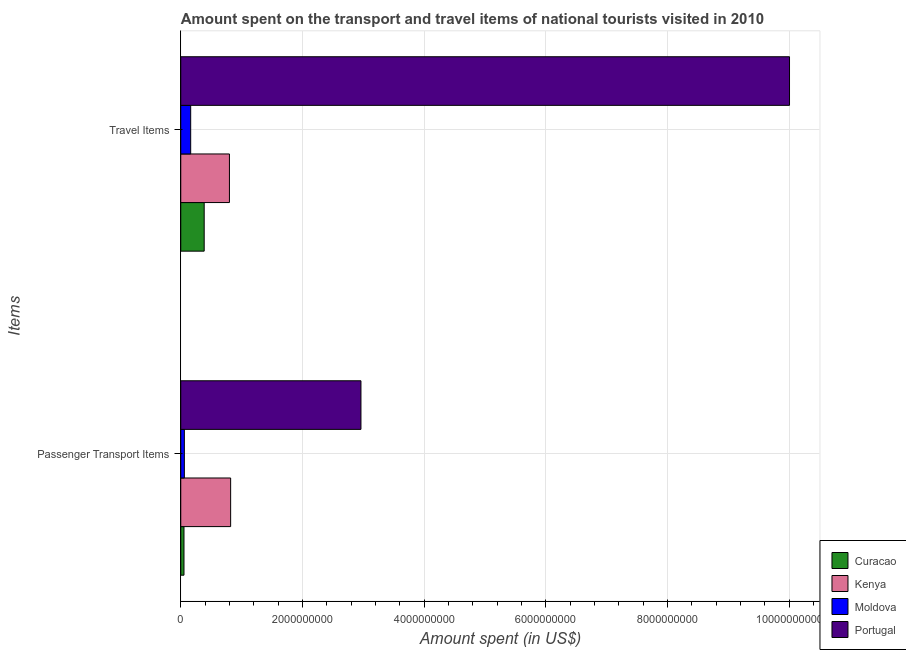How many different coloured bars are there?
Make the answer very short. 4. Are the number of bars per tick equal to the number of legend labels?
Keep it short and to the point. Yes. How many bars are there on the 2nd tick from the top?
Your answer should be compact. 4. What is the label of the 1st group of bars from the top?
Ensure brevity in your answer.  Travel Items. What is the amount spent in travel items in Kenya?
Give a very brief answer. 8.00e+08. Across all countries, what is the maximum amount spent on passenger transport items?
Offer a terse response. 2.96e+09. Across all countries, what is the minimum amount spent on passenger transport items?
Offer a terse response. 5.30e+07. In which country was the amount spent in travel items minimum?
Keep it short and to the point. Moldova. What is the total amount spent in travel items in the graph?
Make the answer very short. 1.14e+1. What is the difference between the amount spent on passenger transport items in Curacao and that in Portugal?
Your answer should be very brief. -2.91e+09. What is the difference between the amount spent on passenger transport items in Curacao and the amount spent in travel items in Portugal?
Provide a succinct answer. -9.95e+09. What is the average amount spent on passenger transport items per country?
Offer a terse response. 9.74e+08. What is the difference between the amount spent on passenger transport items and amount spent in travel items in Portugal?
Make the answer very short. -7.04e+09. In how many countries, is the amount spent in travel items greater than 8400000000 US$?
Keep it short and to the point. 1. What is the ratio of the amount spent in travel items in Portugal to that in Curacao?
Provide a succinct answer. 25.99. In how many countries, is the amount spent in travel items greater than the average amount spent in travel items taken over all countries?
Your answer should be very brief. 1. What does the 1st bar from the top in Passenger Transport Items represents?
Make the answer very short. Portugal. What does the 2nd bar from the bottom in Travel Items represents?
Provide a succinct answer. Kenya. What is the difference between two consecutive major ticks on the X-axis?
Ensure brevity in your answer.  2.00e+09. Does the graph contain any zero values?
Make the answer very short. No. What is the title of the graph?
Give a very brief answer. Amount spent on the transport and travel items of national tourists visited in 2010. Does "Comoros" appear as one of the legend labels in the graph?
Your answer should be very brief. No. What is the label or title of the X-axis?
Keep it short and to the point. Amount spent (in US$). What is the label or title of the Y-axis?
Your response must be concise. Items. What is the Amount spent (in US$) of Curacao in Passenger Transport Items?
Keep it short and to the point. 5.30e+07. What is the Amount spent (in US$) in Kenya in Passenger Transport Items?
Give a very brief answer. 8.20e+08. What is the Amount spent (in US$) in Moldova in Passenger Transport Items?
Your answer should be compact. 5.90e+07. What is the Amount spent (in US$) of Portugal in Passenger Transport Items?
Your answer should be very brief. 2.96e+09. What is the Amount spent (in US$) in Curacao in Travel Items?
Your answer should be very brief. 3.85e+08. What is the Amount spent (in US$) in Kenya in Travel Items?
Offer a very short reply. 8.00e+08. What is the Amount spent (in US$) in Moldova in Travel Items?
Your answer should be very brief. 1.63e+08. What is the Amount spent (in US$) of Portugal in Travel Items?
Ensure brevity in your answer.  1.00e+1. Across all Items, what is the maximum Amount spent (in US$) of Curacao?
Your answer should be compact. 3.85e+08. Across all Items, what is the maximum Amount spent (in US$) in Kenya?
Offer a terse response. 8.20e+08. Across all Items, what is the maximum Amount spent (in US$) in Moldova?
Offer a very short reply. 1.63e+08. Across all Items, what is the maximum Amount spent (in US$) of Portugal?
Your answer should be very brief. 1.00e+1. Across all Items, what is the minimum Amount spent (in US$) of Curacao?
Make the answer very short. 5.30e+07. Across all Items, what is the minimum Amount spent (in US$) in Kenya?
Provide a short and direct response. 8.00e+08. Across all Items, what is the minimum Amount spent (in US$) in Moldova?
Provide a succinct answer. 5.90e+07. Across all Items, what is the minimum Amount spent (in US$) of Portugal?
Provide a short and direct response. 2.96e+09. What is the total Amount spent (in US$) in Curacao in the graph?
Give a very brief answer. 4.38e+08. What is the total Amount spent (in US$) of Kenya in the graph?
Give a very brief answer. 1.62e+09. What is the total Amount spent (in US$) in Moldova in the graph?
Offer a very short reply. 2.22e+08. What is the total Amount spent (in US$) of Portugal in the graph?
Your response must be concise. 1.30e+1. What is the difference between the Amount spent (in US$) of Curacao in Passenger Transport Items and that in Travel Items?
Keep it short and to the point. -3.32e+08. What is the difference between the Amount spent (in US$) of Kenya in Passenger Transport Items and that in Travel Items?
Your answer should be very brief. 2.00e+07. What is the difference between the Amount spent (in US$) of Moldova in Passenger Transport Items and that in Travel Items?
Offer a very short reply. -1.04e+08. What is the difference between the Amount spent (in US$) of Portugal in Passenger Transport Items and that in Travel Items?
Provide a short and direct response. -7.04e+09. What is the difference between the Amount spent (in US$) in Curacao in Passenger Transport Items and the Amount spent (in US$) in Kenya in Travel Items?
Ensure brevity in your answer.  -7.47e+08. What is the difference between the Amount spent (in US$) in Curacao in Passenger Transport Items and the Amount spent (in US$) in Moldova in Travel Items?
Give a very brief answer. -1.10e+08. What is the difference between the Amount spent (in US$) in Curacao in Passenger Transport Items and the Amount spent (in US$) in Portugal in Travel Items?
Your answer should be very brief. -9.95e+09. What is the difference between the Amount spent (in US$) in Kenya in Passenger Transport Items and the Amount spent (in US$) in Moldova in Travel Items?
Provide a succinct answer. 6.57e+08. What is the difference between the Amount spent (in US$) in Kenya in Passenger Transport Items and the Amount spent (in US$) in Portugal in Travel Items?
Provide a short and direct response. -9.19e+09. What is the difference between the Amount spent (in US$) of Moldova in Passenger Transport Items and the Amount spent (in US$) of Portugal in Travel Items?
Offer a terse response. -9.95e+09. What is the average Amount spent (in US$) of Curacao per Items?
Your answer should be very brief. 2.19e+08. What is the average Amount spent (in US$) in Kenya per Items?
Offer a terse response. 8.10e+08. What is the average Amount spent (in US$) in Moldova per Items?
Keep it short and to the point. 1.11e+08. What is the average Amount spent (in US$) of Portugal per Items?
Your answer should be very brief. 6.48e+09. What is the difference between the Amount spent (in US$) in Curacao and Amount spent (in US$) in Kenya in Passenger Transport Items?
Your answer should be compact. -7.67e+08. What is the difference between the Amount spent (in US$) in Curacao and Amount spent (in US$) in Moldova in Passenger Transport Items?
Your response must be concise. -6.00e+06. What is the difference between the Amount spent (in US$) of Curacao and Amount spent (in US$) of Portugal in Passenger Transport Items?
Provide a succinct answer. -2.91e+09. What is the difference between the Amount spent (in US$) of Kenya and Amount spent (in US$) of Moldova in Passenger Transport Items?
Make the answer very short. 7.61e+08. What is the difference between the Amount spent (in US$) of Kenya and Amount spent (in US$) of Portugal in Passenger Transport Items?
Offer a terse response. -2.14e+09. What is the difference between the Amount spent (in US$) of Moldova and Amount spent (in US$) of Portugal in Passenger Transport Items?
Ensure brevity in your answer.  -2.90e+09. What is the difference between the Amount spent (in US$) of Curacao and Amount spent (in US$) of Kenya in Travel Items?
Ensure brevity in your answer.  -4.15e+08. What is the difference between the Amount spent (in US$) of Curacao and Amount spent (in US$) of Moldova in Travel Items?
Provide a short and direct response. 2.22e+08. What is the difference between the Amount spent (in US$) of Curacao and Amount spent (in US$) of Portugal in Travel Items?
Ensure brevity in your answer.  -9.62e+09. What is the difference between the Amount spent (in US$) in Kenya and Amount spent (in US$) in Moldova in Travel Items?
Your answer should be compact. 6.37e+08. What is the difference between the Amount spent (in US$) of Kenya and Amount spent (in US$) of Portugal in Travel Items?
Provide a succinct answer. -9.21e+09. What is the difference between the Amount spent (in US$) of Moldova and Amount spent (in US$) of Portugal in Travel Items?
Your answer should be compact. -9.84e+09. What is the ratio of the Amount spent (in US$) in Curacao in Passenger Transport Items to that in Travel Items?
Offer a very short reply. 0.14. What is the ratio of the Amount spent (in US$) in Moldova in Passenger Transport Items to that in Travel Items?
Provide a succinct answer. 0.36. What is the ratio of the Amount spent (in US$) in Portugal in Passenger Transport Items to that in Travel Items?
Give a very brief answer. 0.3. What is the difference between the highest and the second highest Amount spent (in US$) of Curacao?
Your response must be concise. 3.32e+08. What is the difference between the highest and the second highest Amount spent (in US$) of Moldova?
Your answer should be compact. 1.04e+08. What is the difference between the highest and the second highest Amount spent (in US$) in Portugal?
Your response must be concise. 7.04e+09. What is the difference between the highest and the lowest Amount spent (in US$) in Curacao?
Ensure brevity in your answer.  3.32e+08. What is the difference between the highest and the lowest Amount spent (in US$) of Kenya?
Offer a very short reply. 2.00e+07. What is the difference between the highest and the lowest Amount spent (in US$) in Moldova?
Offer a terse response. 1.04e+08. What is the difference between the highest and the lowest Amount spent (in US$) in Portugal?
Your answer should be very brief. 7.04e+09. 